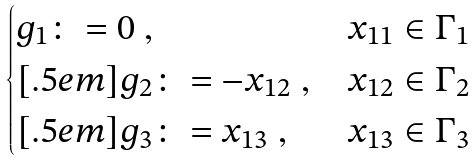<formula> <loc_0><loc_0><loc_500><loc_500>\begin{cases} g _ { 1 } \colon = 0 \ , & \text {$x_{11}\in\Gamma_{1}$} \\ [ . 5 e m ] g _ { 2 } \colon = - x _ { 1 2 } \ , & \text {$x_{12}\in\Gamma_{2}$} \\ [ . 5 e m ] g _ { 3 } \colon = x _ { 1 3 } \ , & \text {$x_{13}\in\Gamma_{3}$} \end{cases}</formula> 